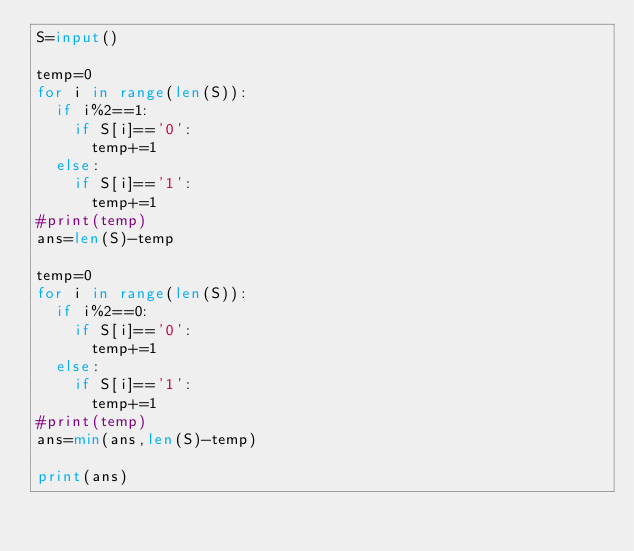Convert code to text. <code><loc_0><loc_0><loc_500><loc_500><_Python_>S=input()

temp=0
for i in range(len(S)):
  if i%2==1:
    if S[i]=='0':
      temp+=1
  else:
    if S[i]=='1':
      temp+=1
#print(temp)
ans=len(S)-temp

temp=0
for i in range(len(S)):
  if i%2==0:
    if S[i]=='0':
      temp+=1
  else:
    if S[i]=='1':
      temp+=1
#print(temp)
ans=min(ans,len(S)-temp)

print(ans)</code> 